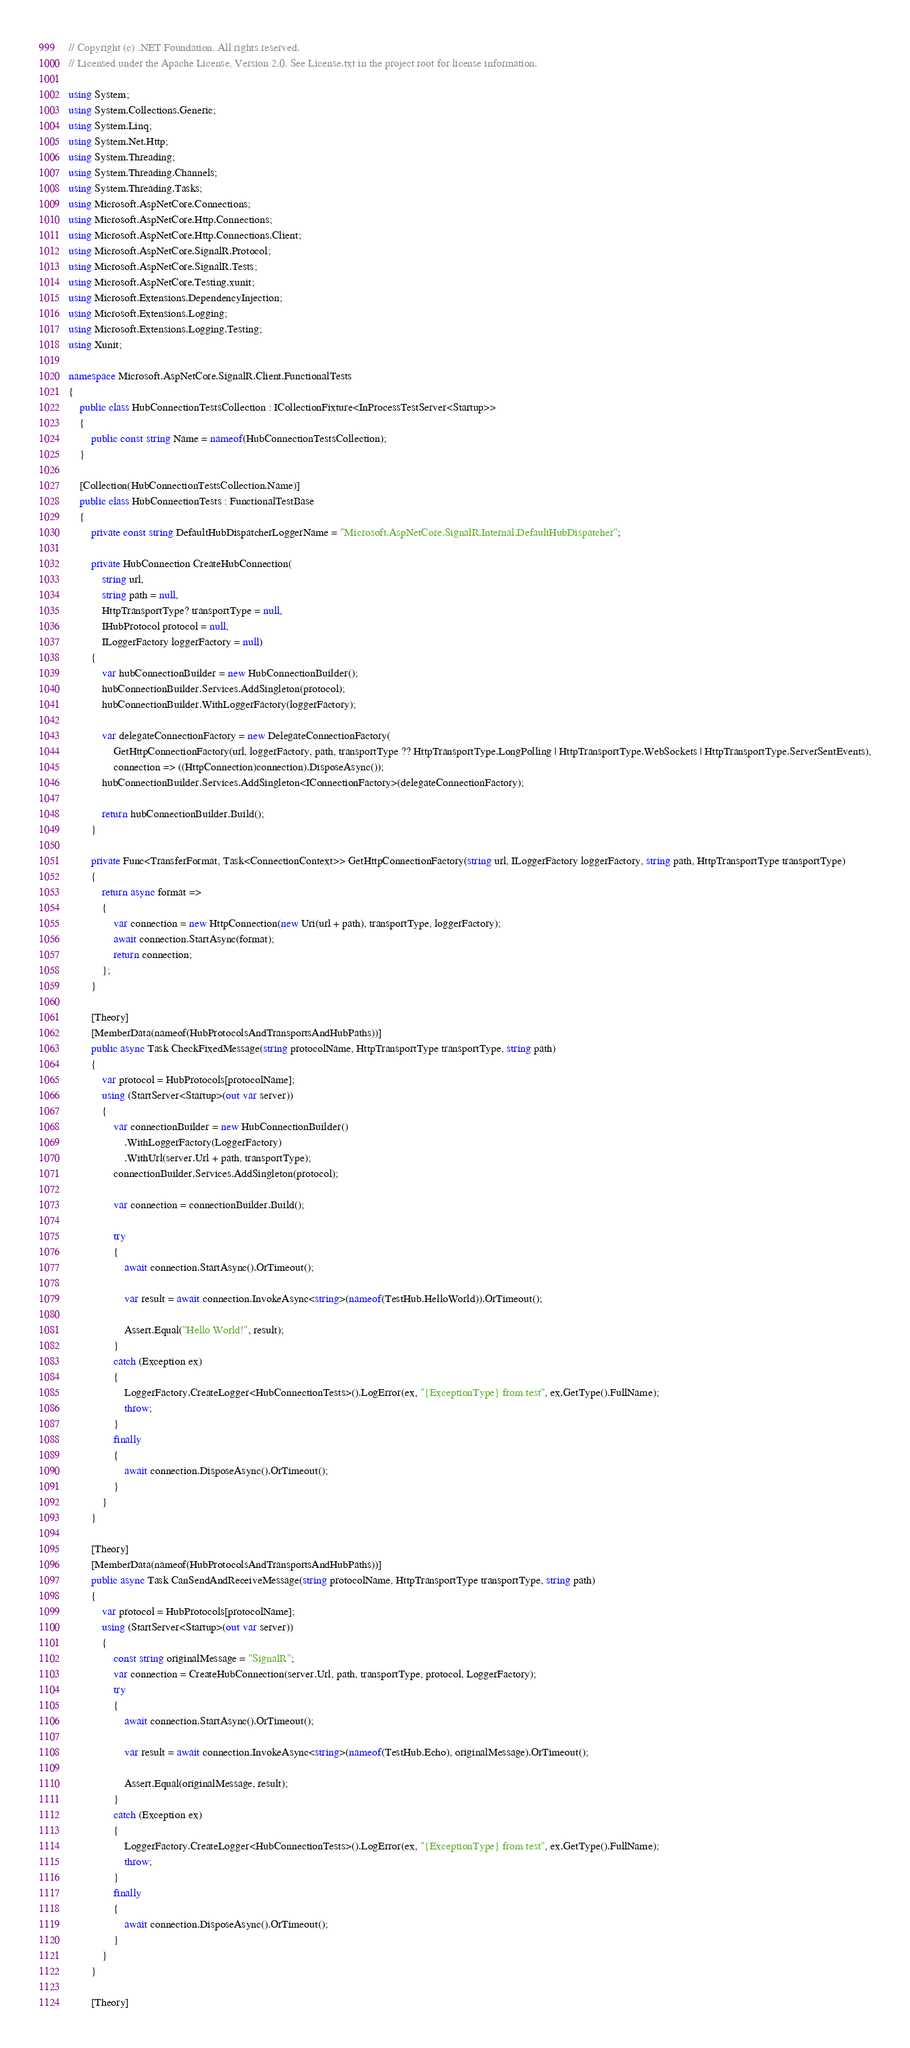<code> <loc_0><loc_0><loc_500><loc_500><_C#_>// Copyright (c) .NET Foundation. All rights reserved.
// Licensed under the Apache License, Version 2.0. See License.txt in the project root for license information.

using System;
using System.Collections.Generic;
using System.Linq;
using System.Net.Http;
using System.Threading;
using System.Threading.Channels;
using System.Threading.Tasks;
using Microsoft.AspNetCore.Connections;
using Microsoft.AspNetCore.Http.Connections;
using Microsoft.AspNetCore.Http.Connections.Client;
using Microsoft.AspNetCore.SignalR.Protocol;
using Microsoft.AspNetCore.SignalR.Tests;
using Microsoft.AspNetCore.Testing.xunit;
using Microsoft.Extensions.DependencyInjection;
using Microsoft.Extensions.Logging;
using Microsoft.Extensions.Logging.Testing;
using Xunit;

namespace Microsoft.AspNetCore.SignalR.Client.FunctionalTests
{
    public class HubConnectionTestsCollection : ICollectionFixture<InProcessTestServer<Startup>>
    {
        public const string Name = nameof(HubConnectionTestsCollection);
    }

    [Collection(HubConnectionTestsCollection.Name)]
    public class HubConnectionTests : FunctionalTestBase
    {
        private const string DefaultHubDispatcherLoggerName = "Microsoft.AspNetCore.SignalR.Internal.DefaultHubDispatcher";

        private HubConnection CreateHubConnection(
            string url,
            string path = null,
            HttpTransportType? transportType = null,
            IHubProtocol protocol = null,
            ILoggerFactory loggerFactory = null)
        {
            var hubConnectionBuilder = new HubConnectionBuilder();
            hubConnectionBuilder.Services.AddSingleton(protocol);
            hubConnectionBuilder.WithLoggerFactory(loggerFactory);

            var delegateConnectionFactory = new DelegateConnectionFactory(
                GetHttpConnectionFactory(url, loggerFactory, path, transportType ?? HttpTransportType.LongPolling | HttpTransportType.WebSockets | HttpTransportType.ServerSentEvents),
                connection => ((HttpConnection)connection).DisposeAsync());
            hubConnectionBuilder.Services.AddSingleton<IConnectionFactory>(delegateConnectionFactory);

            return hubConnectionBuilder.Build();
        }

        private Func<TransferFormat, Task<ConnectionContext>> GetHttpConnectionFactory(string url, ILoggerFactory loggerFactory, string path, HttpTransportType transportType)
        {
            return async format =>
            {
                var connection = new HttpConnection(new Uri(url + path), transportType, loggerFactory);
                await connection.StartAsync(format);
                return connection;
            };
        }

        [Theory]
        [MemberData(nameof(HubProtocolsAndTransportsAndHubPaths))]
        public async Task CheckFixedMessage(string protocolName, HttpTransportType transportType, string path)
        {
            var protocol = HubProtocols[protocolName];
            using (StartServer<Startup>(out var server))
            {
                var connectionBuilder = new HubConnectionBuilder()
                    .WithLoggerFactory(LoggerFactory)
                    .WithUrl(server.Url + path, transportType);
                connectionBuilder.Services.AddSingleton(protocol);

                var connection = connectionBuilder.Build();

                try
                {
                    await connection.StartAsync().OrTimeout();

                    var result = await connection.InvokeAsync<string>(nameof(TestHub.HelloWorld)).OrTimeout();

                    Assert.Equal("Hello World!", result);
                }
                catch (Exception ex)
                {
                    LoggerFactory.CreateLogger<HubConnectionTests>().LogError(ex, "{ExceptionType} from test", ex.GetType().FullName);
                    throw;
                }
                finally
                {
                    await connection.DisposeAsync().OrTimeout();
                }
            }
        }

        [Theory]
        [MemberData(nameof(HubProtocolsAndTransportsAndHubPaths))]
        public async Task CanSendAndReceiveMessage(string protocolName, HttpTransportType transportType, string path)
        {
            var protocol = HubProtocols[protocolName];
            using (StartServer<Startup>(out var server))
            {
                const string originalMessage = "SignalR";
                var connection = CreateHubConnection(server.Url, path, transportType, protocol, LoggerFactory);
                try
                {
                    await connection.StartAsync().OrTimeout();

                    var result = await connection.InvokeAsync<string>(nameof(TestHub.Echo), originalMessage).OrTimeout();

                    Assert.Equal(originalMessage, result);
                }
                catch (Exception ex)
                {
                    LoggerFactory.CreateLogger<HubConnectionTests>().LogError(ex, "{ExceptionType} from test", ex.GetType().FullName);
                    throw;
                }
                finally
                {
                    await connection.DisposeAsync().OrTimeout();
                }
            }
        }

        [Theory]</code> 